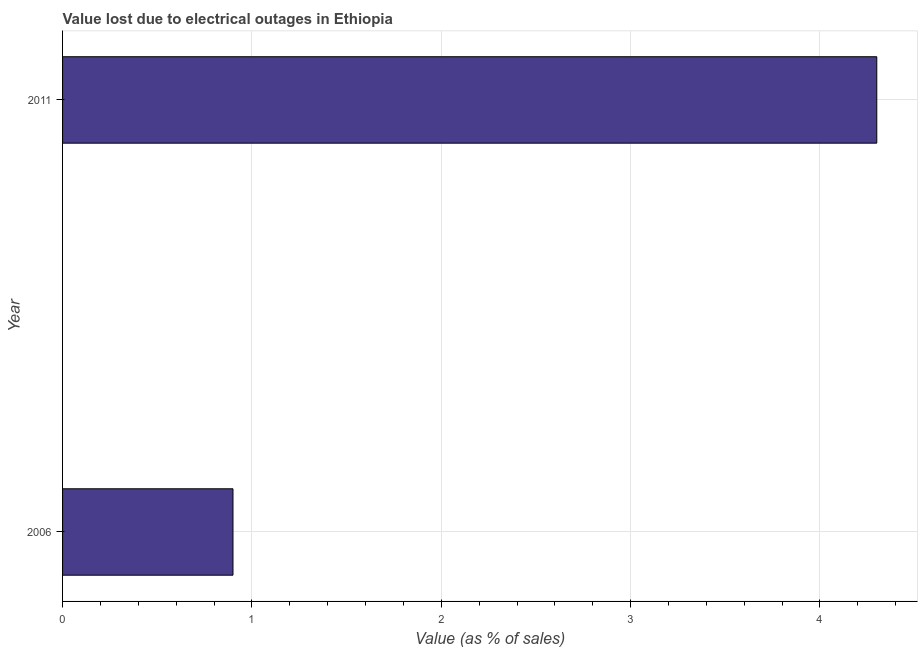Does the graph contain grids?
Offer a terse response. Yes. What is the title of the graph?
Offer a terse response. Value lost due to electrical outages in Ethiopia. What is the label or title of the X-axis?
Your answer should be very brief. Value (as % of sales). Across all years, what is the maximum value lost due to electrical outages?
Keep it short and to the point. 4.3. Across all years, what is the minimum value lost due to electrical outages?
Offer a very short reply. 0.9. What is the sum of the value lost due to electrical outages?
Provide a short and direct response. 5.2. What is the difference between the value lost due to electrical outages in 2006 and 2011?
Your answer should be compact. -3.4. What is the median value lost due to electrical outages?
Provide a succinct answer. 2.6. Do a majority of the years between 2011 and 2006 (inclusive) have value lost due to electrical outages greater than 1.6 %?
Give a very brief answer. No. What is the ratio of the value lost due to electrical outages in 2006 to that in 2011?
Your answer should be very brief. 0.21. Is the value lost due to electrical outages in 2006 less than that in 2011?
Provide a succinct answer. Yes. In how many years, is the value lost due to electrical outages greater than the average value lost due to electrical outages taken over all years?
Offer a very short reply. 1. How many bars are there?
Make the answer very short. 2. What is the difference between two consecutive major ticks on the X-axis?
Make the answer very short. 1. What is the Value (as % of sales) of 2006?
Ensure brevity in your answer.  0.9. What is the ratio of the Value (as % of sales) in 2006 to that in 2011?
Offer a terse response. 0.21. 